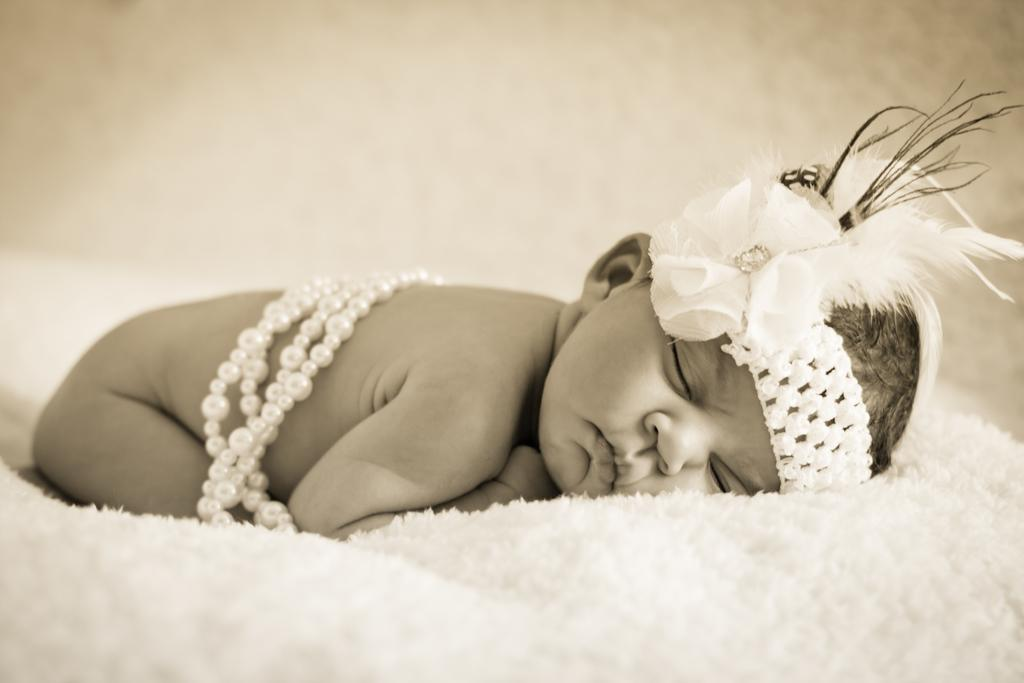What is the color scheme of the image? The image is black and white. Who or what is the main subject of the image? There is a baby in the image. What is the baby laying on? The baby is laying on a white bed sheet. Can you describe the background of the image? The background of the image is blurred. What is the baby talking about with the school in the image? There is no school present in the image, and the baby is not talking. 